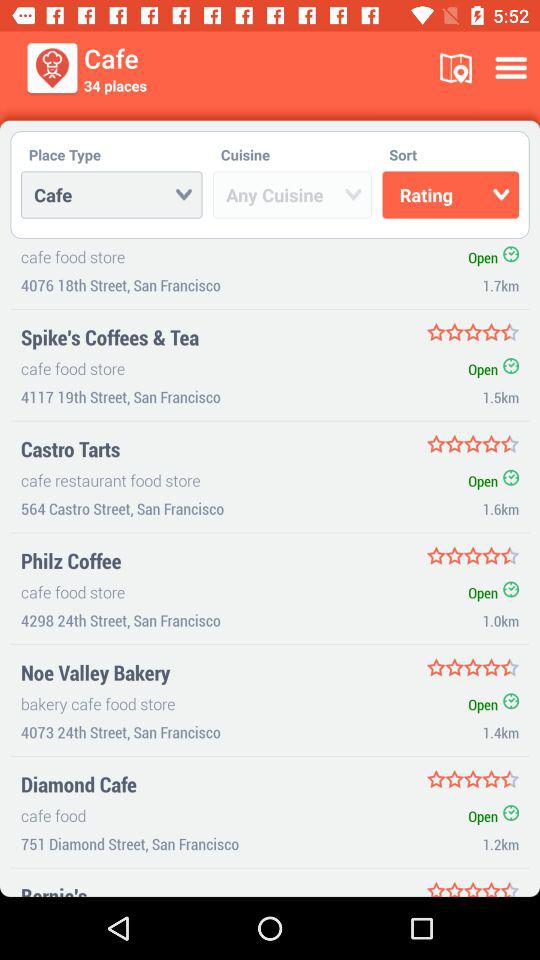What is the rating of "Philz Coffee"? The rating is 4.5 stars. 